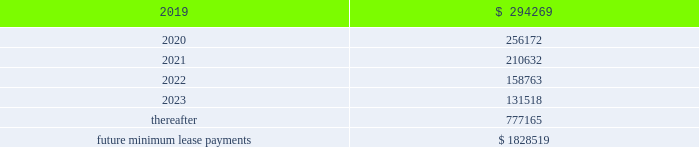Business subsequent to the acquisition .
The liabilities for these payments are classified as level 3 liabilities because the related fair value measurement , which is determined using an income approach , includes significant inputs not observable in the market .
Financial assets and liabilities not measured at fair value our debt is reflected on the consolidated balance sheets at cost .
Based on market conditions as of december 31 , 2018 and 2017 , the fair value of our credit agreement borrowings reasonably approximated the carrying values of $ 1.7 billion and $ 2.0 billion , respectively .
In addition , based on market conditions , the fair values of the outstanding borrowings under the receivables facility reasonably approximated the carrying values of $ 110 million and $ 100 million at december 31 , 2018 and december 31 , 2017 , respectively .
As of december 31 , 2018 and december 31 , 2017 , the fair values of the u.s .
Notes ( 2023 ) were approximately $ 574 million and $ 615 million , respectively , compared to a carrying value of $ 600 million at each date .
As of december 31 , 2018 and december 31 , 2017 , the fair values of the euro notes ( 2024 ) were approximately $ 586 million and $ 658 million compared to carrying values of $ 573 million and $ 600 million , respectively .
As of december 31 , 2018 , the fair value of the euro notes ( 2026/28 ) approximated the carrying value of $ 1.1 billion .
The fair value measurements of the borrowings under our credit agreement and receivables facility are classified as level 2 within the fair value hierarchy since they are determined based upon significant inputs observable in the market , including interest rates on recent financing transactions with similar terms and maturities .
We estimated the fair value by calculating the upfront cash payment a market participant would require at december 31 , 2018 to assume these obligations .
The fair value of our u.s .
Notes ( 2023 ) is classified as level 1 within the fair value hierarchy since it is determined based upon observable market inputs including quoted market prices in an active market .
The fair values of our euro notes ( 2024 ) and euro notes ( 2026/28 ) are determined based upon observable market inputs including quoted market prices in markets that are not active , and therefore are classified as level 2 within the fair value hierarchy .
Note 13 .
Commitments and contingencies operating leases we are obligated under noncancelable operating leases for corporate office space , warehouse and distribution facilities , trucks and certain equipment .
The future minimum lease commitments under these leases at december 31 , 2018 are as follows ( in thousands ) : years ending december 31: .
Rental expense for operating leases was approximately $ 300 million , $ 247 million , and $ 212 million during the years ended december 31 , 2018 , 2017 and 2016 , respectively .
We guarantee the residual values of the majority of our truck and equipment operating leases .
The residual values decline over the lease terms to a defined percentage of original cost .
In the event the lessor does not realize the residual value when a piece of equipment is sold , we would be responsible for a portion of the shortfall .
Similarly , if the lessor realizes more than the residual value when a piece of equipment is sold , we would be paid the amount realized over the residual value .
Had we terminated all of our operating leases subject to these guarantees at december 31 , 2018 , our portion of the guaranteed residual value would have totaled approximately $ 76 million .
We have not recorded a liability for the guaranteed residual value of equipment under operating leases as the recovery on disposition of the equipment under the leases is expected to approximate the guaranteed residual value .
Litigation and related contingencies we have certain contingencies resulting from litigation , claims and other commitments and are subject to a variety of environmental and pollution control laws and regulations incident to the ordinary course of business .
We currently expect that the resolution of such contingencies will not materially affect our financial position , results of operations or cash flows. .
What was the percentage change in rental expenses from 2016 to 2017? 
Computations: ((247 - 212) / 212)
Answer: 0.16509. 